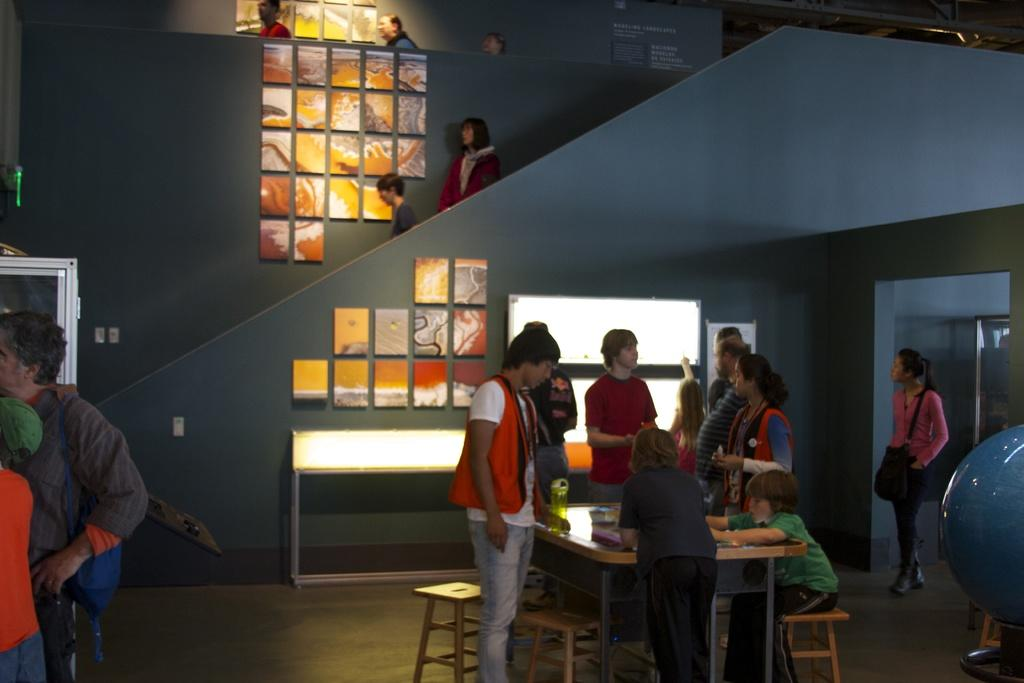What is the general arrangement of people in the image? There is a group of people standing in the image, and a boy sitting with a table in front of him. Where are the majority of the people located in the image? The majority of the people are standing on the left side of the image. Can you describe the position of the boy in the image? The boy is sitting with a table in front of him. What type of harmony is being played by the cat in the image? There is no cat present in the image, so it is not possible to determine what type of harmony might be played. 